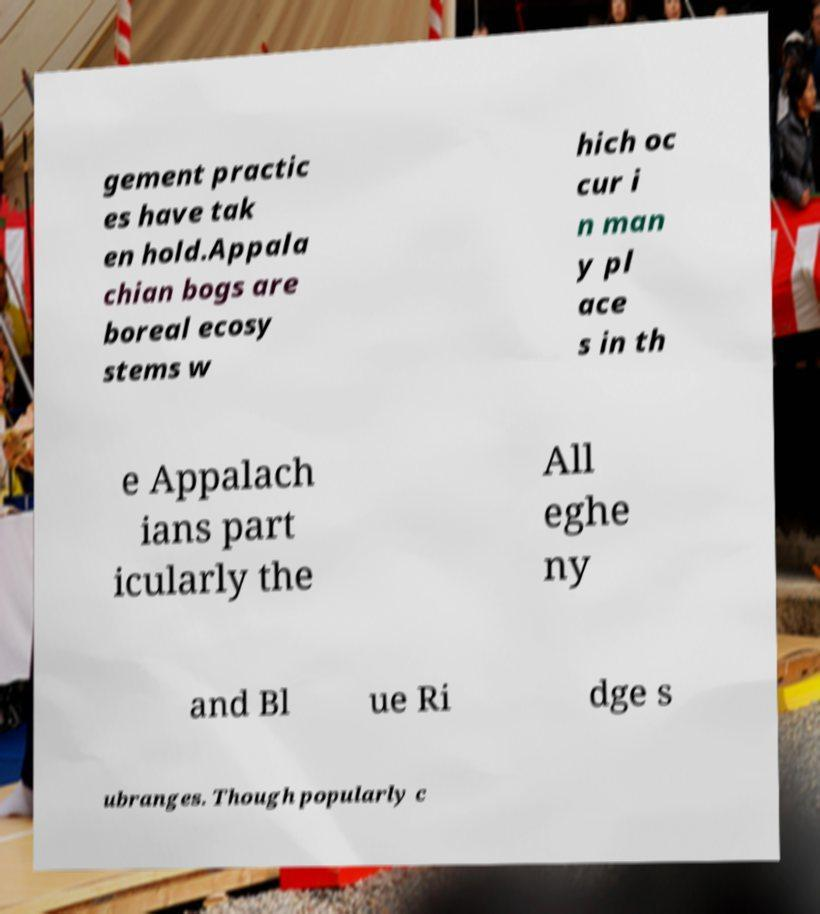For documentation purposes, I need the text within this image transcribed. Could you provide that? gement practic es have tak en hold.Appala chian bogs are boreal ecosy stems w hich oc cur i n man y pl ace s in th e Appalach ians part icularly the All eghe ny and Bl ue Ri dge s ubranges. Though popularly c 